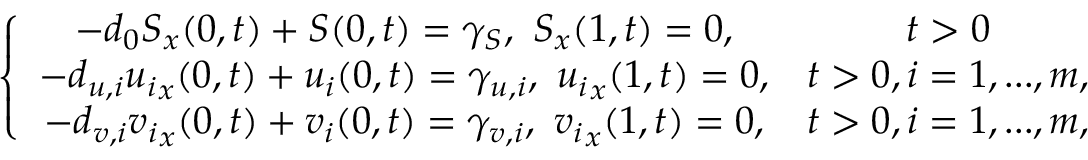<formula> <loc_0><loc_0><loc_500><loc_500>\left \{ \begin{array} { c c } { - d _ { 0 } S _ { x } ( 0 , t ) + S ( 0 , t ) = \gamma _ { S } , \, S _ { x } ( 1 , t ) = 0 , } & { t > 0 } \\ { - d _ { u , i } { u _ { i } } _ { x } ( 0 , t ) + u _ { i } ( 0 , t ) = \gamma _ { u , i } , \, { u _ { i } } _ { x } ( 1 , t ) = 0 , } & { t > 0 , i = 1 , \dots , m , } \\ { - d _ { v , i } { v _ { i } } _ { x } ( 0 , t ) + v _ { i } ( 0 , t ) = \gamma _ { v , i } , \, { v _ { i } } _ { x } ( 1 , t ) = 0 , } & { t > 0 , i = 1 , \dots , m , } \end{array}</formula> 